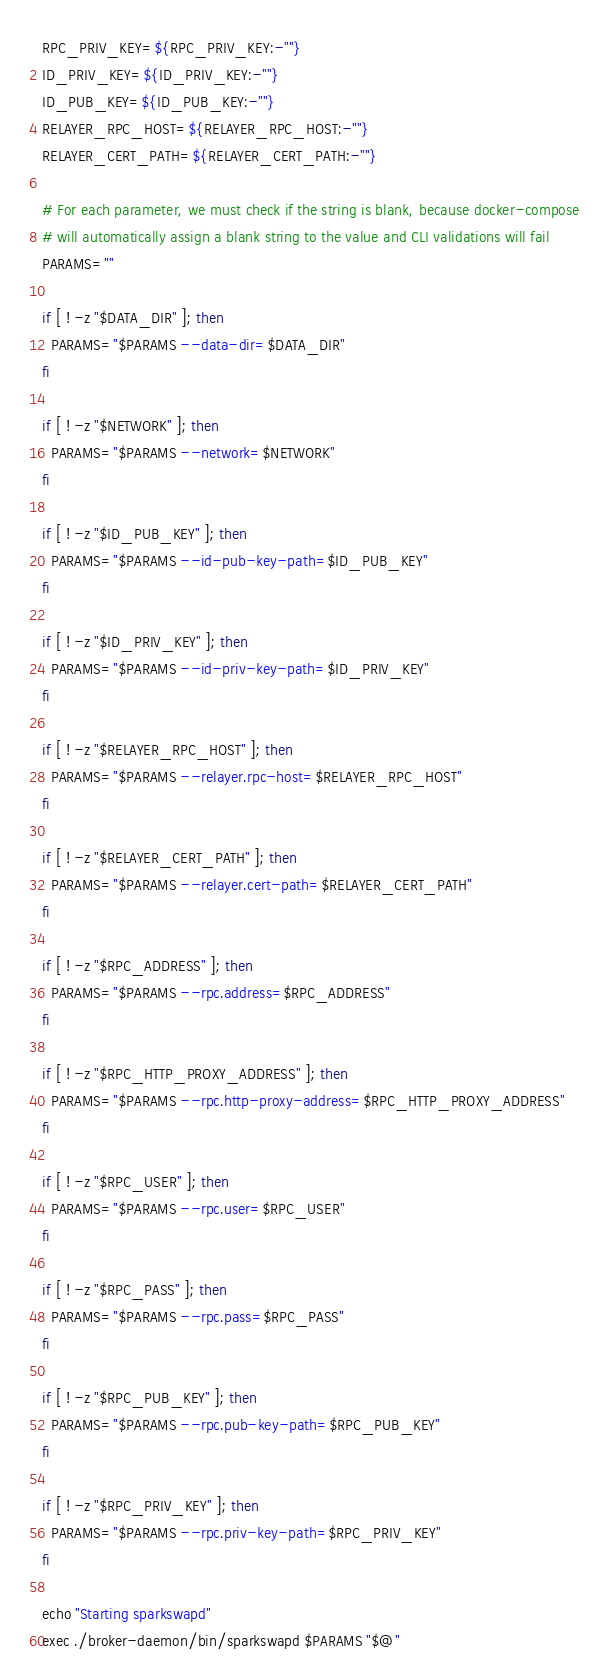<code> <loc_0><loc_0><loc_500><loc_500><_Bash_>RPC_PRIV_KEY=${RPC_PRIV_KEY:-""}
ID_PRIV_KEY=${ID_PRIV_KEY:-""}
ID_PUB_KEY=${ID_PUB_KEY:-""}
RELAYER_RPC_HOST=${RELAYER_RPC_HOST:-""}
RELAYER_CERT_PATH=${RELAYER_CERT_PATH:-""}

# For each parameter, we must check if the string is blank, because docker-compose
# will automatically assign a blank string to the value and CLI validations will fail
PARAMS=""

if [ ! -z "$DATA_DIR" ]; then
  PARAMS="$PARAMS --data-dir=$DATA_DIR"
fi

if [ ! -z "$NETWORK" ]; then
  PARAMS="$PARAMS --network=$NETWORK"
fi

if [ ! -z "$ID_PUB_KEY" ]; then
  PARAMS="$PARAMS --id-pub-key-path=$ID_PUB_KEY"
fi

if [ ! -z "$ID_PRIV_KEY" ]; then
  PARAMS="$PARAMS --id-priv-key-path=$ID_PRIV_KEY"
fi

if [ ! -z "$RELAYER_RPC_HOST" ]; then
  PARAMS="$PARAMS --relayer.rpc-host=$RELAYER_RPC_HOST"
fi

if [ ! -z "$RELAYER_CERT_PATH" ]; then
  PARAMS="$PARAMS --relayer.cert-path=$RELAYER_CERT_PATH"
fi

if [ ! -z "$RPC_ADDRESS" ]; then
  PARAMS="$PARAMS --rpc.address=$RPC_ADDRESS"
fi

if [ ! -z "$RPC_HTTP_PROXY_ADDRESS" ]; then
  PARAMS="$PARAMS --rpc.http-proxy-address=$RPC_HTTP_PROXY_ADDRESS"
fi

if [ ! -z "$RPC_USER" ]; then
  PARAMS="$PARAMS --rpc.user=$RPC_USER"
fi

if [ ! -z "$RPC_PASS" ]; then
  PARAMS="$PARAMS --rpc.pass=$RPC_PASS"
fi

if [ ! -z "$RPC_PUB_KEY" ]; then
  PARAMS="$PARAMS --rpc.pub-key-path=$RPC_PUB_KEY"
fi

if [ ! -z "$RPC_PRIV_KEY" ]; then
  PARAMS="$PARAMS --rpc.priv-key-path=$RPC_PRIV_KEY"
fi

echo "Starting sparkswapd"
exec ./broker-daemon/bin/sparkswapd $PARAMS "$@"
</code> 